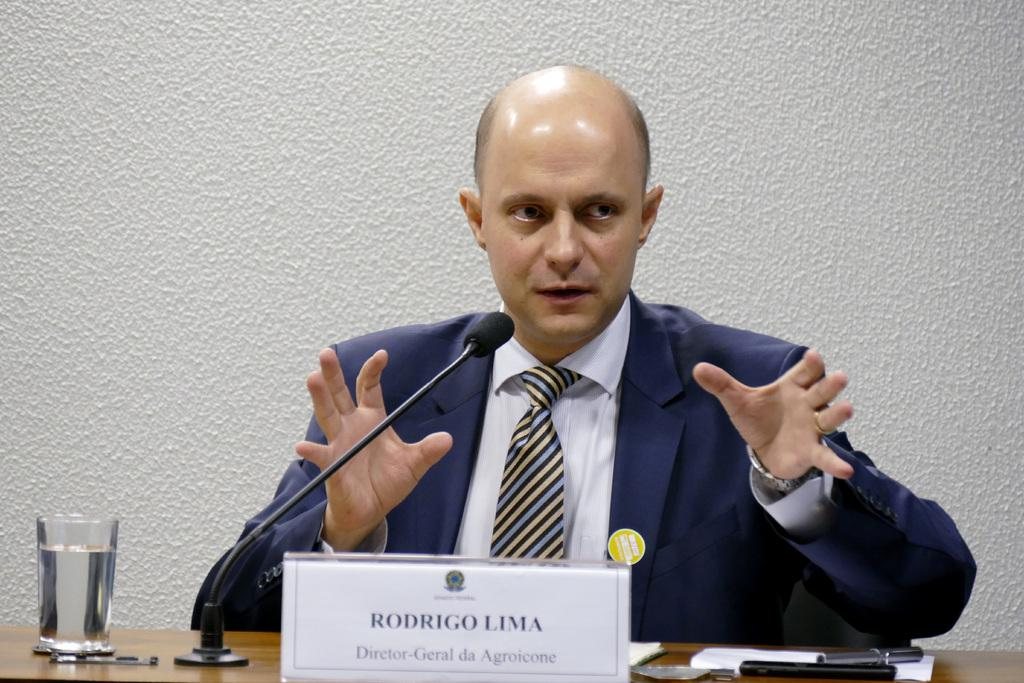Who is in the image? There is a man in the image. What is the man wearing? The man is wearing a blue suit. What can be seen on the table in the image? There is a glass, a nameplate, and a mic on the table. What is the background of the image? There is a wall in the background of the image. Can you see any waves in the image? There are no waves present in the image; it features a man in a blue suit, a table with various items, and a wall in the background. 